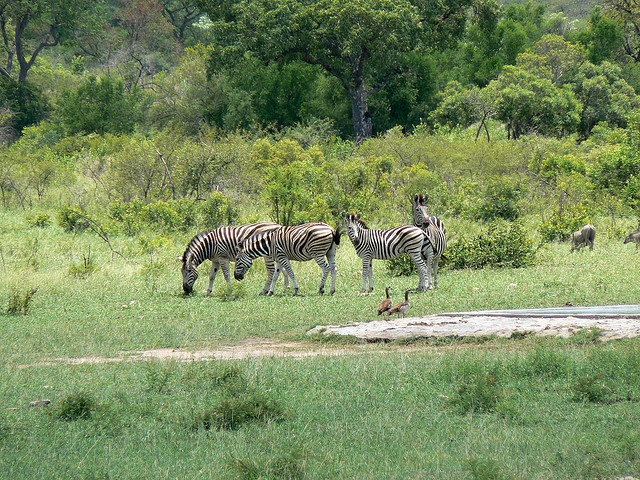Describe the objects in this image and their specific colors. I can see zebra in darkblue, black, gray, darkgray, and olive tones, zebra in darkblue, darkgray, gray, black, and ivory tones, zebra in darkblue, gray, black, olive, and darkgray tones, zebra in darkblue, gray, darkgray, black, and ivory tones, and bird in darkblue, darkgray, gray, tan, and black tones in this image. 